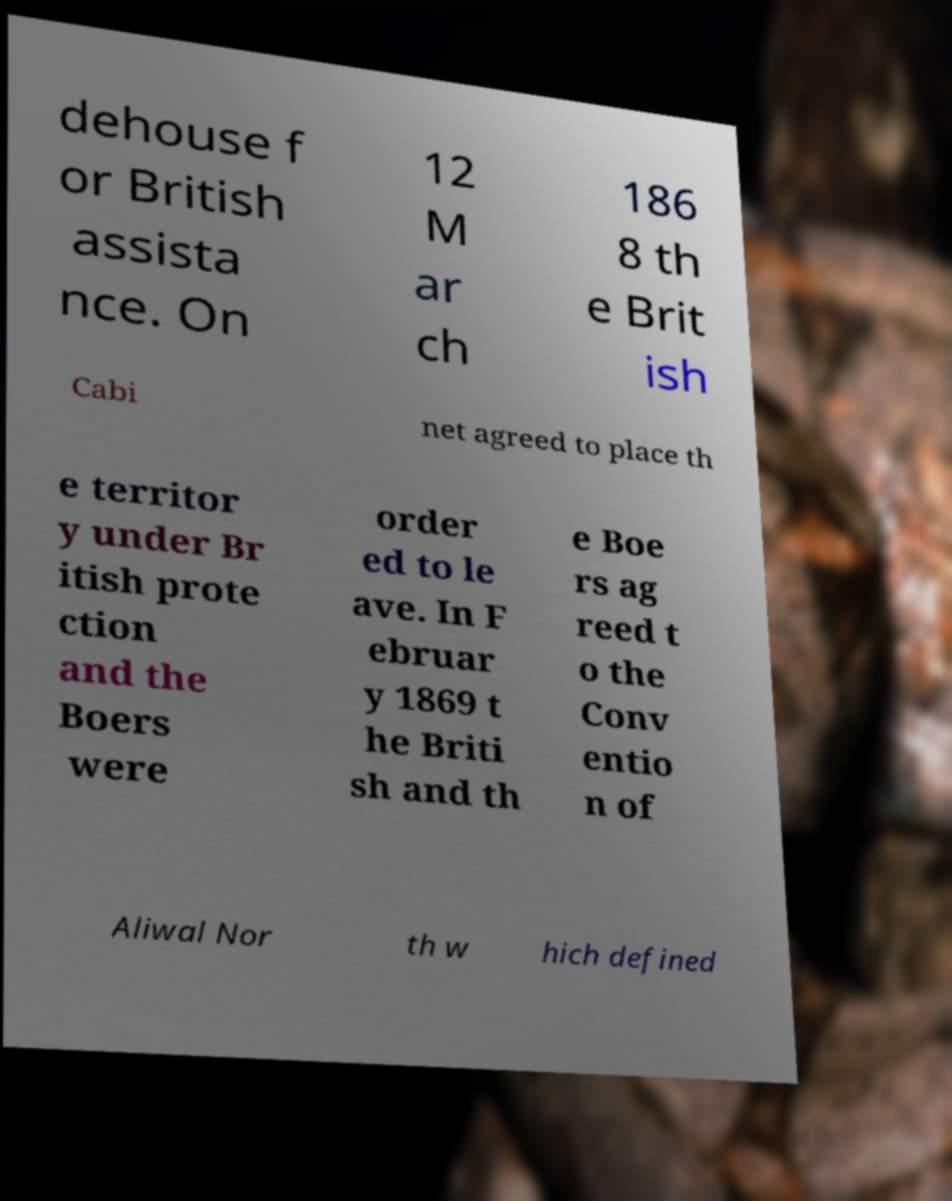Could you assist in decoding the text presented in this image and type it out clearly? dehouse f or British assista nce. On 12 M ar ch 186 8 th e Brit ish Cabi net agreed to place th e territor y under Br itish prote ction and the Boers were order ed to le ave. In F ebruar y 1869 t he Briti sh and th e Boe rs ag reed t o the Conv entio n of Aliwal Nor th w hich defined 